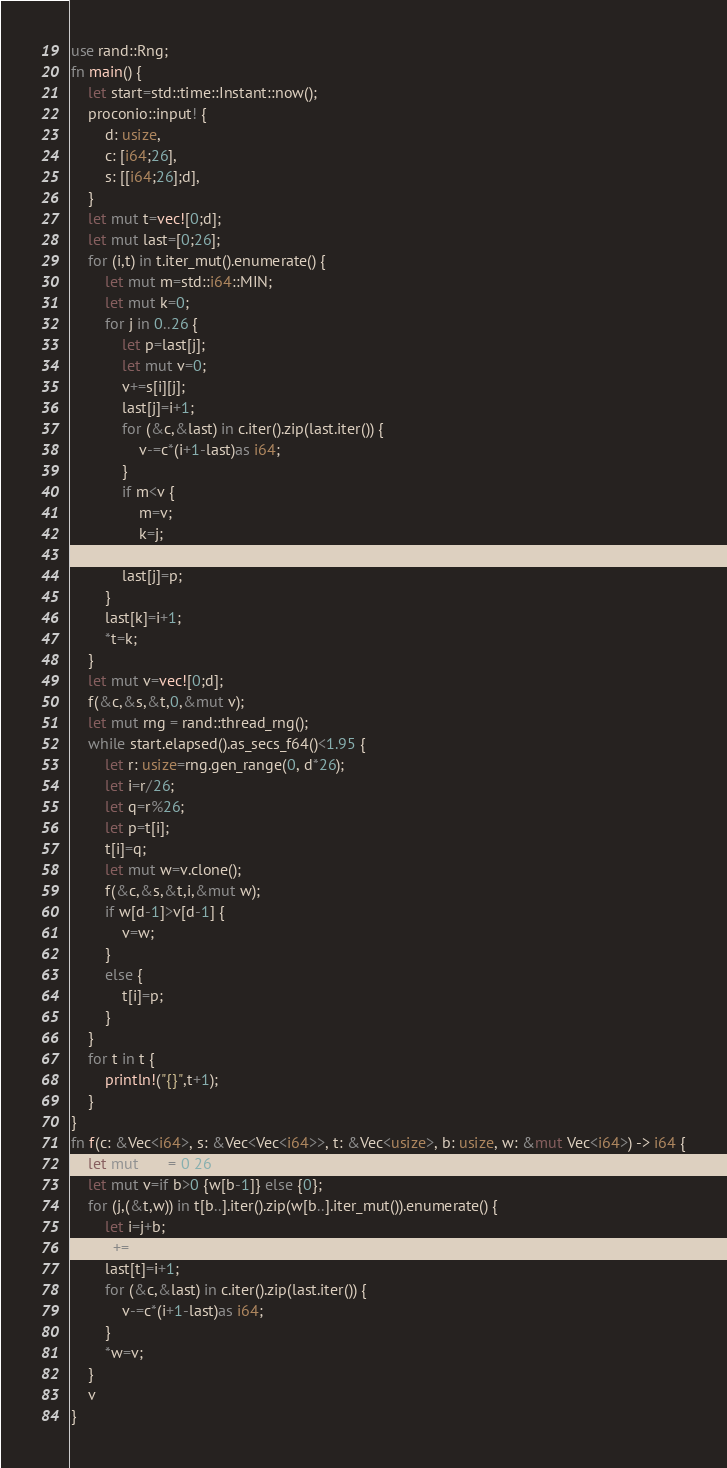Convert code to text. <code><loc_0><loc_0><loc_500><loc_500><_Rust_>use rand::Rng;
fn main() {
    let start=std::time::Instant::now();
    proconio::input! {
        d: usize,
        c: [i64;26],
        s: [[i64;26];d],
    }
    let mut t=vec![0;d];
    let mut last=[0;26];
    for (i,t) in t.iter_mut().enumerate() {
        let mut m=std::i64::MIN;
        let mut k=0;
        for j in 0..26 {
            let p=last[j];
            let mut v=0;
            v+=s[i][j];
            last[j]=i+1;
            for (&c,&last) in c.iter().zip(last.iter()) {
                v-=c*(i+1-last)as i64;
            }
            if m<v {
                m=v;
                k=j;
            }
            last[j]=p;
        }
        last[k]=i+1;
        *t=k;
    }
    let mut v=vec![0;d];
    f(&c,&s,&t,0,&mut v);
    let mut rng = rand::thread_rng();
    while start.elapsed().as_secs_f64()<1.95 {
        let r: usize=rng.gen_range(0, d*26);
        let i=r/26;
        let q=r%26;
        let p=t[i];
        t[i]=q;
        let mut w=v.clone();
        f(&c,&s,&t,i,&mut w);
        if w[d-1]>v[d-1] {
            v=w;
        }
        else {
            t[i]=p;
        }
    }
    for t in t {
        println!("{}",t+1);
    }
}
fn f(c: &Vec<i64>, s: &Vec<Vec<i64>>, t: &Vec<usize>, b: usize, w: &mut Vec<i64>) -> i64 {
    let mut last=[0;26];
    let mut v=if b>0 {w[b-1]} else {0};
    for (j,(&t,w)) in t[b..].iter().zip(w[b..].iter_mut()).enumerate() {
        let i=j+b;
        v+=s[i][t];
        last[t]=i+1;
        for (&c,&last) in c.iter().zip(last.iter()) {
            v-=c*(i+1-last)as i64;
        }
        *w=v;
    }
    v
}</code> 